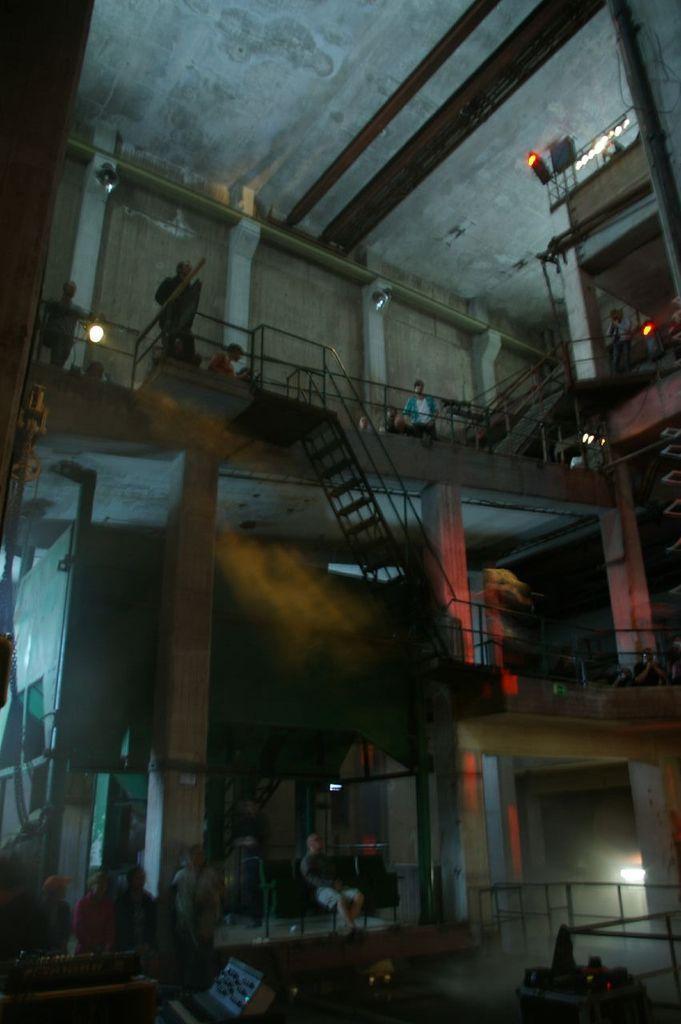Describe this image in one or two sentences. This image is taken inside the building. In this image there are people and we can see chairs. There are stairs and we can see lights. There are railings. At the top there is a roof. 